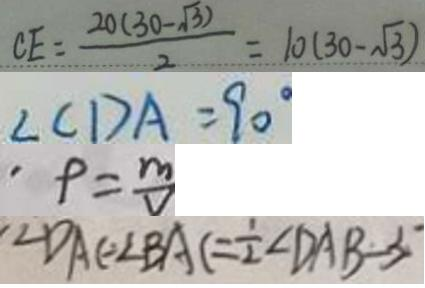Convert formula to latex. <formula><loc_0><loc_0><loc_500><loc_500>C E = \frac { 2 0 ( 3 0 - \sqrt { 3 } ) } { 2 } = 1 0 ( 3 0 - \sqrt { 3 } ) 
 \angle C D A = 9 0 ^ { \circ } 
 . \rho = \frac { m } { v } 
 \angle D A C = \angle B A C = \frac { 1 } { 2 } \angle D A B - 3</formula> 